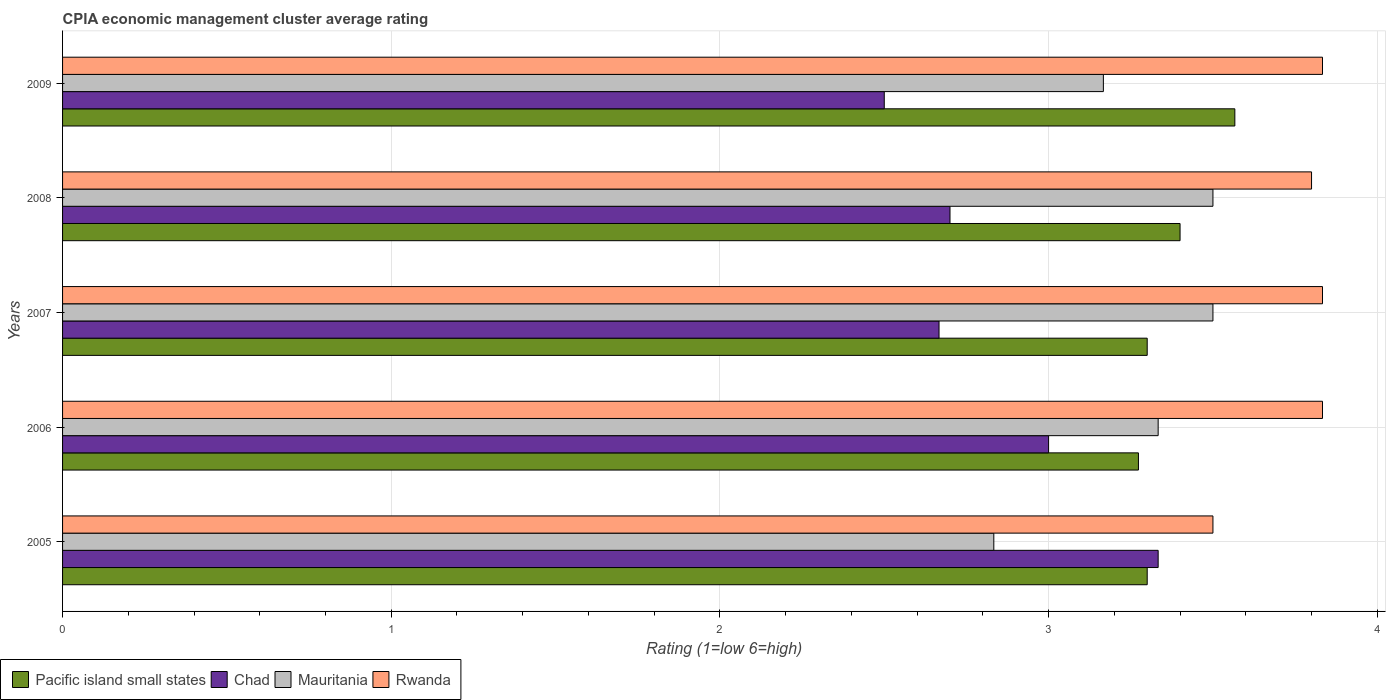How many different coloured bars are there?
Keep it short and to the point. 4. How many groups of bars are there?
Offer a very short reply. 5. Are the number of bars on each tick of the Y-axis equal?
Your answer should be very brief. Yes. What is the label of the 5th group of bars from the top?
Your answer should be very brief. 2005. Across all years, what is the maximum CPIA rating in Mauritania?
Ensure brevity in your answer.  3.5. Across all years, what is the minimum CPIA rating in Rwanda?
Offer a terse response. 3.5. What is the total CPIA rating in Rwanda in the graph?
Provide a succinct answer. 18.8. What is the difference between the CPIA rating in Mauritania in 2005 and that in 2006?
Offer a terse response. -0.5. What is the difference between the CPIA rating in Mauritania in 2009 and the CPIA rating in Pacific island small states in 2008?
Offer a terse response. -0.23. What is the average CPIA rating in Pacific island small states per year?
Offer a terse response. 3.37. In the year 2009, what is the difference between the CPIA rating in Rwanda and CPIA rating in Mauritania?
Offer a very short reply. 0.67. In how many years, is the CPIA rating in Mauritania greater than 3.6 ?
Provide a succinct answer. 0. What is the ratio of the CPIA rating in Mauritania in 2006 to that in 2009?
Your answer should be compact. 1.05. What is the difference between the highest and the second highest CPIA rating in Chad?
Your answer should be compact. 0.33. What is the difference between the highest and the lowest CPIA rating in Chad?
Make the answer very short. 0.83. Is the sum of the CPIA rating in Pacific island small states in 2005 and 2009 greater than the maximum CPIA rating in Chad across all years?
Offer a very short reply. Yes. Is it the case that in every year, the sum of the CPIA rating in Rwanda and CPIA rating in Pacific island small states is greater than the sum of CPIA rating in Mauritania and CPIA rating in Chad?
Offer a terse response. Yes. What does the 3rd bar from the top in 2007 represents?
Give a very brief answer. Chad. What does the 1st bar from the bottom in 2009 represents?
Make the answer very short. Pacific island small states. How many bars are there?
Offer a terse response. 20. Are all the bars in the graph horizontal?
Give a very brief answer. Yes. How many years are there in the graph?
Keep it short and to the point. 5. What is the difference between two consecutive major ticks on the X-axis?
Your answer should be compact. 1. Does the graph contain any zero values?
Ensure brevity in your answer.  No. What is the title of the graph?
Your answer should be compact. CPIA economic management cluster average rating. What is the Rating (1=low 6=high) of Pacific island small states in 2005?
Your response must be concise. 3.3. What is the Rating (1=low 6=high) of Chad in 2005?
Your response must be concise. 3.33. What is the Rating (1=low 6=high) of Mauritania in 2005?
Make the answer very short. 2.83. What is the Rating (1=low 6=high) in Rwanda in 2005?
Offer a terse response. 3.5. What is the Rating (1=low 6=high) in Pacific island small states in 2006?
Give a very brief answer. 3.27. What is the Rating (1=low 6=high) in Mauritania in 2006?
Make the answer very short. 3.33. What is the Rating (1=low 6=high) of Rwanda in 2006?
Your answer should be very brief. 3.83. What is the Rating (1=low 6=high) in Pacific island small states in 2007?
Give a very brief answer. 3.3. What is the Rating (1=low 6=high) in Chad in 2007?
Offer a terse response. 2.67. What is the Rating (1=low 6=high) of Rwanda in 2007?
Give a very brief answer. 3.83. What is the Rating (1=low 6=high) in Pacific island small states in 2008?
Keep it short and to the point. 3.4. What is the Rating (1=low 6=high) of Chad in 2008?
Keep it short and to the point. 2.7. What is the Rating (1=low 6=high) of Mauritania in 2008?
Provide a short and direct response. 3.5. What is the Rating (1=low 6=high) of Pacific island small states in 2009?
Ensure brevity in your answer.  3.57. What is the Rating (1=low 6=high) in Chad in 2009?
Your response must be concise. 2.5. What is the Rating (1=low 6=high) of Mauritania in 2009?
Your answer should be very brief. 3.17. What is the Rating (1=low 6=high) of Rwanda in 2009?
Make the answer very short. 3.83. Across all years, what is the maximum Rating (1=low 6=high) of Pacific island small states?
Make the answer very short. 3.57. Across all years, what is the maximum Rating (1=low 6=high) in Chad?
Keep it short and to the point. 3.33. Across all years, what is the maximum Rating (1=low 6=high) of Mauritania?
Give a very brief answer. 3.5. Across all years, what is the maximum Rating (1=low 6=high) in Rwanda?
Your answer should be very brief. 3.83. Across all years, what is the minimum Rating (1=low 6=high) of Pacific island small states?
Offer a very short reply. 3.27. Across all years, what is the minimum Rating (1=low 6=high) of Chad?
Make the answer very short. 2.5. Across all years, what is the minimum Rating (1=low 6=high) in Mauritania?
Provide a succinct answer. 2.83. What is the total Rating (1=low 6=high) in Pacific island small states in the graph?
Provide a succinct answer. 16.84. What is the total Rating (1=low 6=high) in Mauritania in the graph?
Make the answer very short. 16.33. What is the difference between the Rating (1=low 6=high) in Pacific island small states in 2005 and that in 2006?
Give a very brief answer. 0.03. What is the difference between the Rating (1=low 6=high) in Mauritania in 2005 and that in 2007?
Offer a terse response. -0.67. What is the difference between the Rating (1=low 6=high) of Pacific island small states in 2005 and that in 2008?
Offer a terse response. -0.1. What is the difference between the Rating (1=low 6=high) of Chad in 2005 and that in 2008?
Offer a very short reply. 0.63. What is the difference between the Rating (1=low 6=high) of Mauritania in 2005 and that in 2008?
Provide a succinct answer. -0.67. What is the difference between the Rating (1=low 6=high) in Rwanda in 2005 and that in 2008?
Ensure brevity in your answer.  -0.3. What is the difference between the Rating (1=low 6=high) in Pacific island small states in 2005 and that in 2009?
Give a very brief answer. -0.27. What is the difference between the Rating (1=low 6=high) of Chad in 2005 and that in 2009?
Provide a short and direct response. 0.83. What is the difference between the Rating (1=low 6=high) in Mauritania in 2005 and that in 2009?
Ensure brevity in your answer.  -0.33. What is the difference between the Rating (1=low 6=high) of Rwanda in 2005 and that in 2009?
Offer a terse response. -0.33. What is the difference between the Rating (1=low 6=high) of Pacific island small states in 2006 and that in 2007?
Provide a succinct answer. -0.03. What is the difference between the Rating (1=low 6=high) of Pacific island small states in 2006 and that in 2008?
Ensure brevity in your answer.  -0.13. What is the difference between the Rating (1=low 6=high) of Chad in 2006 and that in 2008?
Ensure brevity in your answer.  0.3. What is the difference between the Rating (1=low 6=high) of Mauritania in 2006 and that in 2008?
Ensure brevity in your answer.  -0.17. What is the difference between the Rating (1=low 6=high) in Pacific island small states in 2006 and that in 2009?
Your response must be concise. -0.29. What is the difference between the Rating (1=low 6=high) in Mauritania in 2006 and that in 2009?
Keep it short and to the point. 0.17. What is the difference between the Rating (1=low 6=high) of Pacific island small states in 2007 and that in 2008?
Ensure brevity in your answer.  -0.1. What is the difference between the Rating (1=low 6=high) of Chad in 2007 and that in 2008?
Ensure brevity in your answer.  -0.03. What is the difference between the Rating (1=low 6=high) of Rwanda in 2007 and that in 2008?
Your response must be concise. 0.03. What is the difference between the Rating (1=low 6=high) of Pacific island small states in 2007 and that in 2009?
Give a very brief answer. -0.27. What is the difference between the Rating (1=low 6=high) in Pacific island small states in 2008 and that in 2009?
Make the answer very short. -0.17. What is the difference between the Rating (1=low 6=high) of Mauritania in 2008 and that in 2009?
Offer a very short reply. 0.33. What is the difference between the Rating (1=low 6=high) of Rwanda in 2008 and that in 2009?
Offer a very short reply. -0.03. What is the difference between the Rating (1=low 6=high) in Pacific island small states in 2005 and the Rating (1=low 6=high) in Mauritania in 2006?
Provide a short and direct response. -0.03. What is the difference between the Rating (1=low 6=high) of Pacific island small states in 2005 and the Rating (1=low 6=high) of Rwanda in 2006?
Ensure brevity in your answer.  -0.53. What is the difference between the Rating (1=low 6=high) of Chad in 2005 and the Rating (1=low 6=high) of Rwanda in 2006?
Provide a short and direct response. -0.5. What is the difference between the Rating (1=low 6=high) in Mauritania in 2005 and the Rating (1=low 6=high) in Rwanda in 2006?
Your answer should be very brief. -1. What is the difference between the Rating (1=low 6=high) of Pacific island small states in 2005 and the Rating (1=low 6=high) of Chad in 2007?
Make the answer very short. 0.63. What is the difference between the Rating (1=low 6=high) in Pacific island small states in 2005 and the Rating (1=low 6=high) in Mauritania in 2007?
Offer a terse response. -0.2. What is the difference between the Rating (1=low 6=high) in Pacific island small states in 2005 and the Rating (1=low 6=high) in Rwanda in 2007?
Make the answer very short. -0.53. What is the difference between the Rating (1=low 6=high) in Chad in 2005 and the Rating (1=low 6=high) in Rwanda in 2007?
Your answer should be compact. -0.5. What is the difference between the Rating (1=low 6=high) in Pacific island small states in 2005 and the Rating (1=low 6=high) in Rwanda in 2008?
Provide a succinct answer. -0.5. What is the difference between the Rating (1=low 6=high) in Chad in 2005 and the Rating (1=low 6=high) in Mauritania in 2008?
Give a very brief answer. -0.17. What is the difference between the Rating (1=low 6=high) in Chad in 2005 and the Rating (1=low 6=high) in Rwanda in 2008?
Offer a very short reply. -0.47. What is the difference between the Rating (1=low 6=high) of Mauritania in 2005 and the Rating (1=low 6=high) of Rwanda in 2008?
Provide a short and direct response. -0.97. What is the difference between the Rating (1=low 6=high) of Pacific island small states in 2005 and the Rating (1=low 6=high) of Mauritania in 2009?
Offer a very short reply. 0.13. What is the difference between the Rating (1=low 6=high) of Pacific island small states in 2005 and the Rating (1=low 6=high) of Rwanda in 2009?
Your answer should be compact. -0.53. What is the difference between the Rating (1=low 6=high) in Chad in 2005 and the Rating (1=low 6=high) in Rwanda in 2009?
Provide a short and direct response. -0.5. What is the difference between the Rating (1=low 6=high) of Pacific island small states in 2006 and the Rating (1=low 6=high) of Chad in 2007?
Make the answer very short. 0.61. What is the difference between the Rating (1=low 6=high) of Pacific island small states in 2006 and the Rating (1=low 6=high) of Mauritania in 2007?
Your answer should be compact. -0.23. What is the difference between the Rating (1=low 6=high) in Pacific island small states in 2006 and the Rating (1=low 6=high) in Rwanda in 2007?
Your response must be concise. -0.56. What is the difference between the Rating (1=low 6=high) of Chad in 2006 and the Rating (1=low 6=high) of Rwanda in 2007?
Make the answer very short. -0.83. What is the difference between the Rating (1=low 6=high) in Pacific island small states in 2006 and the Rating (1=low 6=high) in Chad in 2008?
Provide a short and direct response. 0.57. What is the difference between the Rating (1=low 6=high) of Pacific island small states in 2006 and the Rating (1=low 6=high) of Mauritania in 2008?
Your response must be concise. -0.23. What is the difference between the Rating (1=low 6=high) in Pacific island small states in 2006 and the Rating (1=low 6=high) in Rwanda in 2008?
Your answer should be compact. -0.53. What is the difference between the Rating (1=low 6=high) of Chad in 2006 and the Rating (1=low 6=high) of Mauritania in 2008?
Offer a terse response. -0.5. What is the difference between the Rating (1=low 6=high) in Chad in 2006 and the Rating (1=low 6=high) in Rwanda in 2008?
Offer a terse response. -0.8. What is the difference between the Rating (1=low 6=high) in Mauritania in 2006 and the Rating (1=low 6=high) in Rwanda in 2008?
Ensure brevity in your answer.  -0.47. What is the difference between the Rating (1=low 6=high) of Pacific island small states in 2006 and the Rating (1=low 6=high) of Chad in 2009?
Offer a terse response. 0.77. What is the difference between the Rating (1=low 6=high) in Pacific island small states in 2006 and the Rating (1=low 6=high) in Mauritania in 2009?
Provide a succinct answer. 0.11. What is the difference between the Rating (1=low 6=high) of Pacific island small states in 2006 and the Rating (1=low 6=high) of Rwanda in 2009?
Provide a short and direct response. -0.56. What is the difference between the Rating (1=low 6=high) of Chad in 2006 and the Rating (1=low 6=high) of Mauritania in 2009?
Your answer should be very brief. -0.17. What is the difference between the Rating (1=low 6=high) in Chad in 2006 and the Rating (1=low 6=high) in Rwanda in 2009?
Ensure brevity in your answer.  -0.83. What is the difference between the Rating (1=low 6=high) in Mauritania in 2006 and the Rating (1=low 6=high) in Rwanda in 2009?
Your response must be concise. -0.5. What is the difference between the Rating (1=low 6=high) of Pacific island small states in 2007 and the Rating (1=low 6=high) of Mauritania in 2008?
Your answer should be compact. -0.2. What is the difference between the Rating (1=low 6=high) in Chad in 2007 and the Rating (1=low 6=high) in Mauritania in 2008?
Offer a terse response. -0.83. What is the difference between the Rating (1=low 6=high) of Chad in 2007 and the Rating (1=low 6=high) of Rwanda in 2008?
Offer a very short reply. -1.13. What is the difference between the Rating (1=low 6=high) in Pacific island small states in 2007 and the Rating (1=low 6=high) in Mauritania in 2009?
Offer a very short reply. 0.13. What is the difference between the Rating (1=low 6=high) of Pacific island small states in 2007 and the Rating (1=low 6=high) of Rwanda in 2009?
Your answer should be very brief. -0.53. What is the difference between the Rating (1=low 6=high) in Chad in 2007 and the Rating (1=low 6=high) in Mauritania in 2009?
Give a very brief answer. -0.5. What is the difference between the Rating (1=low 6=high) in Chad in 2007 and the Rating (1=low 6=high) in Rwanda in 2009?
Provide a succinct answer. -1.17. What is the difference between the Rating (1=low 6=high) in Pacific island small states in 2008 and the Rating (1=low 6=high) in Mauritania in 2009?
Offer a terse response. 0.23. What is the difference between the Rating (1=low 6=high) of Pacific island small states in 2008 and the Rating (1=low 6=high) of Rwanda in 2009?
Keep it short and to the point. -0.43. What is the difference between the Rating (1=low 6=high) in Chad in 2008 and the Rating (1=low 6=high) in Mauritania in 2009?
Keep it short and to the point. -0.47. What is the difference between the Rating (1=low 6=high) in Chad in 2008 and the Rating (1=low 6=high) in Rwanda in 2009?
Offer a terse response. -1.13. What is the difference between the Rating (1=low 6=high) of Mauritania in 2008 and the Rating (1=low 6=high) of Rwanda in 2009?
Provide a succinct answer. -0.33. What is the average Rating (1=low 6=high) of Pacific island small states per year?
Offer a terse response. 3.37. What is the average Rating (1=low 6=high) in Chad per year?
Your answer should be compact. 2.84. What is the average Rating (1=low 6=high) in Mauritania per year?
Make the answer very short. 3.27. What is the average Rating (1=low 6=high) in Rwanda per year?
Your response must be concise. 3.76. In the year 2005, what is the difference between the Rating (1=low 6=high) of Pacific island small states and Rating (1=low 6=high) of Chad?
Your response must be concise. -0.03. In the year 2005, what is the difference between the Rating (1=low 6=high) in Pacific island small states and Rating (1=low 6=high) in Mauritania?
Keep it short and to the point. 0.47. In the year 2005, what is the difference between the Rating (1=low 6=high) in Pacific island small states and Rating (1=low 6=high) in Rwanda?
Give a very brief answer. -0.2. In the year 2005, what is the difference between the Rating (1=low 6=high) in Chad and Rating (1=low 6=high) in Mauritania?
Your answer should be very brief. 0.5. In the year 2006, what is the difference between the Rating (1=low 6=high) of Pacific island small states and Rating (1=low 6=high) of Chad?
Provide a short and direct response. 0.27. In the year 2006, what is the difference between the Rating (1=low 6=high) of Pacific island small states and Rating (1=low 6=high) of Mauritania?
Provide a short and direct response. -0.06. In the year 2006, what is the difference between the Rating (1=low 6=high) of Pacific island small states and Rating (1=low 6=high) of Rwanda?
Offer a terse response. -0.56. In the year 2006, what is the difference between the Rating (1=low 6=high) of Chad and Rating (1=low 6=high) of Mauritania?
Give a very brief answer. -0.33. In the year 2007, what is the difference between the Rating (1=low 6=high) in Pacific island small states and Rating (1=low 6=high) in Chad?
Make the answer very short. 0.63. In the year 2007, what is the difference between the Rating (1=low 6=high) of Pacific island small states and Rating (1=low 6=high) of Mauritania?
Provide a short and direct response. -0.2. In the year 2007, what is the difference between the Rating (1=low 6=high) of Pacific island small states and Rating (1=low 6=high) of Rwanda?
Give a very brief answer. -0.53. In the year 2007, what is the difference between the Rating (1=low 6=high) in Chad and Rating (1=low 6=high) in Mauritania?
Provide a short and direct response. -0.83. In the year 2007, what is the difference between the Rating (1=low 6=high) of Chad and Rating (1=low 6=high) of Rwanda?
Provide a succinct answer. -1.17. In the year 2007, what is the difference between the Rating (1=low 6=high) in Mauritania and Rating (1=low 6=high) in Rwanda?
Provide a succinct answer. -0.33. In the year 2008, what is the difference between the Rating (1=low 6=high) in Chad and Rating (1=low 6=high) in Mauritania?
Give a very brief answer. -0.8. In the year 2008, what is the difference between the Rating (1=low 6=high) of Chad and Rating (1=low 6=high) of Rwanda?
Your response must be concise. -1.1. In the year 2008, what is the difference between the Rating (1=low 6=high) of Mauritania and Rating (1=low 6=high) of Rwanda?
Your answer should be compact. -0.3. In the year 2009, what is the difference between the Rating (1=low 6=high) in Pacific island small states and Rating (1=low 6=high) in Chad?
Your answer should be compact. 1.07. In the year 2009, what is the difference between the Rating (1=low 6=high) of Pacific island small states and Rating (1=low 6=high) of Mauritania?
Your answer should be very brief. 0.4. In the year 2009, what is the difference between the Rating (1=low 6=high) of Pacific island small states and Rating (1=low 6=high) of Rwanda?
Ensure brevity in your answer.  -0.27. In the year 2009, what is the difference between the Rating (1=low 6=high) of Chad and Rating (1=low 6=high) of Mauritania?
Your answer should be very brief. -0.67. In the year 2009, what is the difference between the Rating (1=low 6=high) of Chad and Rating (1=low 6=high) of Rwanda?
Provide a short and direct response. -1.33. What is the ratio of the Rating (1=low 6=high) of Pacific island small states in 2005 to that in 2006?
Make the answer very short. 1.01. What is the ratio of the Rating (1=low 6=high) in Chad in 2005 to that in 2006?
Your answer should be very brief. 1.11. What is the ratio of the Rating (1=low 6=high) of Pacific island small states in 2005 to that in 2007?
Provide a succinct answer. 1. What is the ratio of the Rating (1=low 6=high) in Mauritania in 2005 to that in 2007?
Ensure brevity in your answer.  0.81. What is the ratio of the Rating (1=low 6=high) of Rwanda in 2005 to that in 2007?
Provide a short and direct response. 0.91. What is the ratio of the Rating (1=low 6=high) in Pacific island small states in 2005 to that in 2008?
Make the answer very short. 0.97. What is the ratio of the Rating (1=low 6=high) of Chad in 2005 to that in 2008?
Your answer should be compact. 1.23. What is the ratio of the Rating (1=low 6=high) in Mauritania in 2005 to that in 2008?
Your answer should be compact. 0.81. What is the ratio of the Rating (1=low 6=high) in Rwanda in 2005 to that in 2008?
Ensure brevity in your answer.  0.92. What is the ratio of the Rating (1=low 6=high) of Pacific island small states in 2005 to that in 2009?
Offer a terse response. 0.93. What is the ratio of the Rating (1=low 6=high) in Mauritania in 2005 to that in 2009?
Your response must be concise. 0.89. What is the ratio of the Rating (1=low 6=high) of Rwanda in 2006 to that in 2007?
Offer a terse response. 1. What is the ratio of the Rating (1=low 6=high) in Pacific island small states in 2006 to that in 2008?
Make the answer very short. 0.96. What is the ratio of the Rating (1=low 6=high) of Rwanda in 2006 to that in 2008?
Your answer should be compact. 1.01. What is the ratio of the Rating (1=low 6=high) in Pacific island small states in 2006 to that in 2009?
Ensure brevity in your answer.  0.92. What is the ratio of the Rating (1=low 6=high) of Chad in 2006 to that in 2009?
Provide a succinct answer. 1.2. What is the ratio of the Rating (1=low 6=high) of Mauritania in 2006 to that in 2009?
Your answer should be compact. 1.05. What is the ratio of the Rating (1=low 6=high) in Rwanda in 2006 to that in 2009?
Offer a terse response. 1. What is the ratio of the Rating (1=low 6=high) in Pacific island small states in 2007 to that in 2008?
Provide a short and direct response. 0.97. What is the ratio of the Rating (1=low 6=high) in Chad in 2007 to that in 2008?
Ensure brevity in your answer.  0.99. What is the ratio of the Rating (1=low 6=high) in Mauritania in 2007 to that in 2008?
Your response must be concise. 1. What is the ratio of the Rating (1=low 6=high) of Rwanda in 2007 to that in 2008?
Ensure brevity in your answer.  1.01. What is the ratio of the Rating (1=low 6=high) of Pacific island small states in 2007 to that in 2009?
Provide a short and direct response. 0.93. What is the ratio of the Rating (1=low 6=high) in Chad in 2007 to that in 2009?
Your answer should be compact. 1.07. What is the ratio of the Rating (1=low 6=high) in Mauritania in 2007 to that in 2009?
Your response must be concise. 1.11. What is the ratio of the Rating (1=low 6=high) in Rwanda in 2007 to that in 2009?
Your answer should be very brief. 1. What is the ratio of the Rating (1=low 6=high) of Pacific island small states in 2008 to that in 2009?
Your answer should be very brief. 0.95. What is the ratio of the Rating (1=low 6=high) of Mauritania in 2008 to that in 2009?
Provide a short and direct response. 1.11. What is the ratio of the Rating (1=low 6=high) in Rwanda in 2008 to that in 2009?
Your answer should be compact. 0.99. What is the difference between the highest and the second highest Rating (1=low 6=high) in Pacific island small states?
Keep it short and to the point. 0.17. What is the difference between the highest and the second highest Rating (1=low 6=high) in Chad?
Ensure brevity in your answer.  0.33. What is the difference between the highest and the second highest Rating (1=low 6=high) in Mauritania?
Ensure brevity in your answer.  0. What is the difference between the highest and the lowest Rating (1=low 6=high) of Pacific island small states?
Give a very brief answer. 0.29. What is the difference between the highest and the lowest Rating (1=low 6=high) in Mauritania?
Your answer should be compact. 0.67. What is the difference between the highest and the lowest Rating (1=low 6=high) in Rwanda?
Provide a succinct answer. 0.33. 